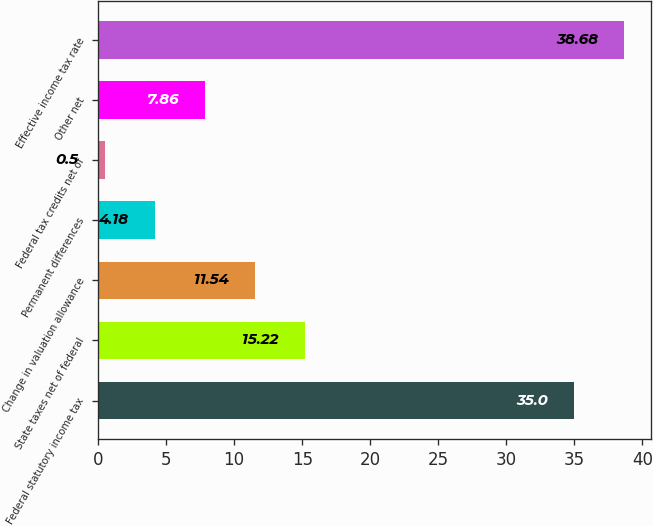Convert chart. <chart><loc_0><loc_0><loc_500><loc_500><bar_chart><fcel>Federal statutory income tax<fcel>State taxes net of federal<fcel>Change in valuation allowance<fcel>Permanent differences<fcel>Federal tax credits net of<fcel>Other net<fcel>Effective income tax rate<nl><fcel>35<fcel>15.22<fcel>11.54<fcel>4.18<fcel>0.5<fcel>7.86<fcel>38.68<nl></chart> 